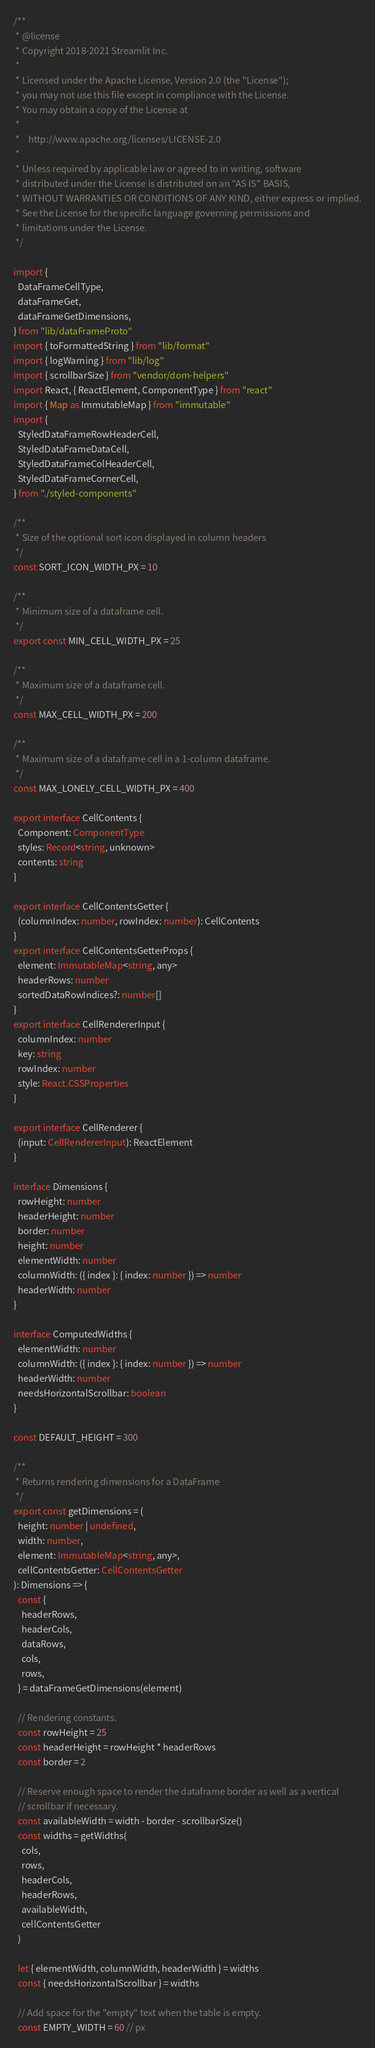<code> <loc_0><loc_0><loc_500><loc_500><_TypeScript_>/**
 * @license
 * Copyright 2018-2021 Streamlit Inc.
 *
 * Licensed under the Apache License, Version 2.0 (the "License");
 * you may not use this file except in compliance with the License.
 * You may obtain a copy of the License at
 *
 *    http://www.apache.org/licenses/LICENSE-2.0
 *
 * Unless required by applicable law or agreed to in writing, software
 * distributed under the License is distributed on an "AS IS" BASIS,
 * WITHOUT WARRANTIES OR CONDITIONS OF ANY KIND, either express or implied.
 * See the License for the specific language governing permissions and
 * limitations under the License.
 */

import {
  DataFrameCellType,
  dataFrameGet,
  dataFrameGetDimensions,
} from "lib/dataFrameProto"
import { toFormattedString } from "lib/format"
import { logWarning } from "lib/log"
import { scrollbarSize } from "vendor/dom-helpers"
import React, { ReactElement, ComponentType } from "react"
import { Map as ImmutableMap } from "immutable"
import {
  StyledDataFrameRowHeaderCell,
  StyledDataFrameDataCell,
  StyledDataFrameColHeaderCell,
  StyledDataFrameCornerCell,
} from "./styled-components"

/**
 * Size of the optional sort icon displayed in column headers
 */
const SORT_ICON_WIDTH_PX = 10

/**
 * Minimum size of a dataframe cell.
 */
export const MIN_CELL_WIDTH_PX = 25

/**
 * Maximum size of a dataframe cell.
 */
const MAX_CELL_WIDTH_PX = 200

/**
 * Maximum size of a dataframe cell in a 1-column dataframe.
 */
const MAX_LONELY_CELL_WIDTH_PX = 400

export interface CellContents {
  Component: ComponentType
  styles: Record<string, unknown>
  contents: string
}

export interface CellContentsGetter {
  (columnIndex: number, rowIndex: number): CellContents
}
export interface CellContentsGetterProps {
  element: ImmutableMap<string, any>
  headerRows: number
  sortedDataRowIndices?: number[]
}
export interface CellRendererInput {
  columnIndex: number
  key: string
  rowIndex: number
  style: React.CSSProperties
}

export interface CellRenderer {
  (input: CellRendererInput): ReactElement
}

interface Dimensions {
  rowHeight: number
  headerHeight: number
  border: number
  height: number
  elementWidth: number
  columnWidth: ({ index }: { index: number }) => number
  headerWidth: number
}

interface ComputedWidths {
  elementWidth: number
  columnWidth: ({ index }: { index: number }) => number
  headerWidth: number
  needsHorizontalScrollbar: boolean
}

const DEFAULT_HEIGHT = 300

/**
 * Returns rendering dimensions for a DataFrame
 */
export const getDimensions = (
  height: number | undefined,
  width: number,
  element: ImmutableMap<string, any>,
  cellContentsGetter: CellContentsGetter
): Dimensions => {
  const {
    headerRows,
    headerCols,
    dataRows,
    cols,
    rows,
  } = dataFrameGetDimensions(element)

  // Rendering constants.
  const rowHeight = 25
  const headerHeight = rowHeight * headerRows
  const border = 2

  // Reserve enough space to render the dataframe border as well as a vertical
  // scrollbar if necessary.
  const availableWidth = width - border - scrollbarSize()
  const widths = getWidths(
    cols,
    rows,
    headerCols,
    headerRows,
    availableWidth,
    cellContentsGetter
  )

  let { elementWidth, columnWidth, headerWidth } = widths
  const { needsHorizontalScrollbar } = widths

  // Add space for the "empty" text when the table is empty.
  const EMPTY_WIDTH = 60 // px</code> 